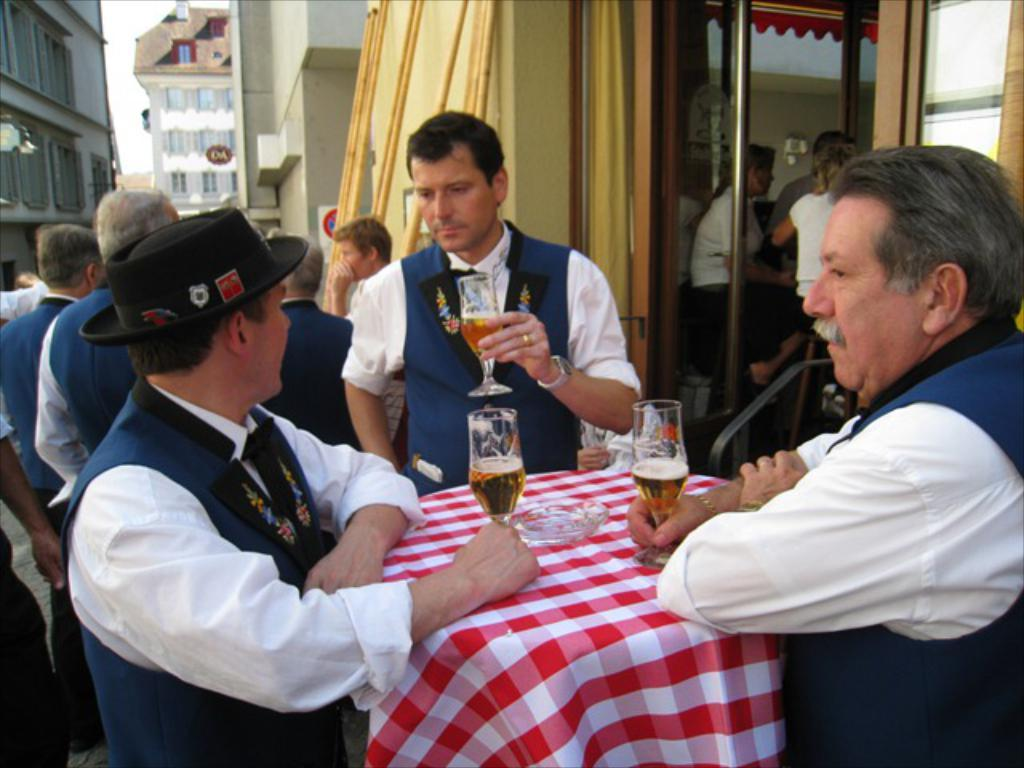How many people are standing in front of the table in the image? There are three people standing in front of the table in the image. What are the three people holding in their hands? The three people are holding wine glasses. Can you describe the people behind them? There is a group of people behind the three people standing in front of the table. What can be seen in the background of the image? Buildings are visible in the background of the image. What type of beetle can be seen crawling on the table in the image? There is no beetle present on the table in the image. What type of polish is being applied to the paper in the image? There is no paper or polish present in the image. 